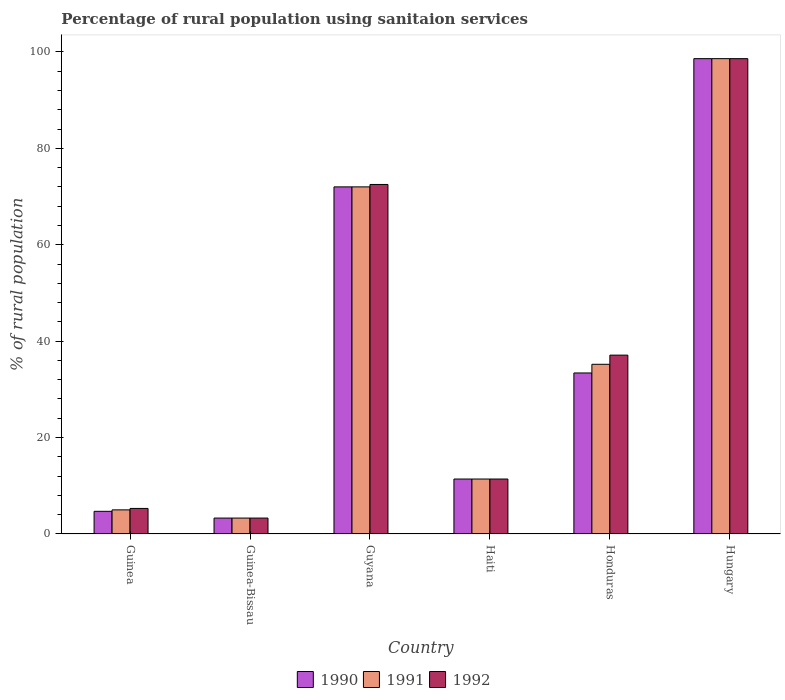How many groups of bars are there?
Offer a very short reply. 6. Are the number of bars per tick equal to the number of legend labels?
Your answer should be compact. Yes. Are the number of bars on each tick of the X-axis equal?
Offer a very short reply. Yes. How many bars are there on the 5th tick from the left?
Keep it short and to the point. 3. How many bars are there on the 1st tick from the right?
Provide a short and direct response. 3. What is the label of the 4th group of bars from the left?
Ensure brevity in your answer.  Haiti. In how many cases, is the number of bars for a given country not equal to the number of legend labels?
Provide a short and direct response. 0. What is the percentage of rural population using sanitaion services in 1990 in Guinea?
Provide a short and direct response. 4.7. Across all countries, what is the maximum percentage of rural population using sanitaion services in 1992?
Your answer should be very brief. 98.6. In which country was the percentage of rural population using sanitaion services in 1990 maximum?
Your answer should be very brief. Hungary. In which country was the percentage of rural population using sanitaion services in 1990 minimum?
Offer a terse response. Guinea-Bissau. What is the total percentage of rural population using sanitaion services in 1992 in the graph?
Provide a short and direct response. 228.2. What is the difference between the percentage of rural population using sanitaion services in 1990 in Guinea-Bissau and the percentage of rural population using sanitaion services in 1991 in Guyana?
Your response must be concise. -68.7. What is the average percentage of rural population using sanitaion services in 1990 per country?
Your answer should be compact. 37.23. In how many countries, is the percentage of rural population using sanitaion services in 1990 greater than 28 %?
Make the answer very short. 3. What is the ratio of the percentage of rural population using sanitaion services in 1992 in Guyana to that in Haiti?
Offer a terse response. 6.36. What is the difference between the highest and the second highest percentage of rural population using sanitaion services in 1990?
Offer a very short reply. 38.6. What is the difference between the highest and the lowest percentage of rural population using sanitaion services in 1992?
Provide a succinct answer. 95.3. In how many countries, is the percentage of rural population using sanitaion services in 1991 greater than the average percentage of rural population using sanitaion services in 1991 taken over all countries?
Make the answer very short. 2. What does the 2nd bar from the right in Guinea represents?
Ensure brevity in your answer.  1991. Are all the bars in the graph horizontal?
Make the answer very short. No. Does the graph contain any zero values?
Provide a short and direct response. No. Where does the legend appear in the graph?
Your answer should be compact. Bottom center. How many legend labels are there?
Offer a very short reply. 3. How are the legend labels stacked?
Provide a succinct answer. Horizontal. What is the title of the graph?
Provide a succinct answer. Percentage of rural population using sanitaion services. What is the label or title of the Y-axis?
Offer a very short reply. % of rural population. What is the % of rural population of 1990 in Guinea?
Ensure brevity in your answer.  4.7. What is the % of rural population in 1991 in Guinea?
Make the answer very short. 5. What is the % of rural population in 1990 in Guinea-Bissau?
Offer a terse response. 3.3. What is the % of rural population in 1991 in Guinea-Bissau?
Give a very brief answer. 3.3. What is the % of rural population of 1990 in Guyana?
Provide a short and direct response. 72. What is the % of rural population of 1992 in Guyana?
Ensure brevity in your answer.  72.5. What is the % of rural population of 1990 in Haiti?
Make the answer very short. 11.4. What is the % of rural population in 1991 in Haiti?
Ensure brevity in your answer.  11.4. What is the % of rural population of 1990 in Honduras?
Your response must be concise. 33.4. What is the % of rural population of 1991 in Honduras?
Make the answer very short. 35.2. What is the % of rural population in 1992 in Honduras?
Ensure brevity in your answer.  37.1. What is the % of rural population of 1990 in Hungary?
Your response must be concise. 98.6. What is the % of rural population in 1991 in Hungary?
Offer a very short reply. 98.6. What is the % of rural population in 1992 in Hungary?
Make the answer very short. 98.6. Across all countries, what is the maximum % of rural population of 1990?
Your response must be concise. 98.6. Across all countries, what is the maximum % of rural population in 1991?
Your answer should be very brief. 98.6. Across all countries, what is the maximum % of rural population in 1992?
Provide a succinct answer. 98.6. Across all countries, what is the minimum % of rural population of 1990?
Give a very brief answer. 3.3. What is the total % of rural population in 1990 in the graph?
Your answer should be compact. 223.4. What is the total % of rural population of 1991 in the graph?
Offer a very short reply. 225.5. What is the total % of rural population in 1992 in the graph?
Your answer should be very brief. 228.2. What is the difference between the % of rural population of 1990 in Guinea and that in Guyana?
Provide a short and direct response. -67.3. What is the difference between the % of rural population of 1991 in Guinea and that in Guyana?
Your answer should be compact. -67. What is the difference between the % of rural population of 1992 in Guinea and that in Guyana?
Provide a succinct answer. -67.2. What is the difference between the % of rural population of 1991 in Guinea and that in Haiti?
Your answer should be very brief. -6.4. What is the difference between the % of rural population in 1990 in Guinea and that in Honduras?
Provide a succinct answer. -28.7. What is the difference between the % of rural population in 1991 in Guinea and that in Honduras?
Make the answer very short. -30.2. What is the difference between the % of rural population in 1992 in Guinea and that in Honduras?
Your answer should be very brief. -31.8. What is the difference between the % of rural population in 1990 in Guinea and that in Hungary?
Your answer should be compact. -93.9. What is the difference between the % of rural population in 1991 in Guinea and that in Hungary?
Ensure brevity in your answer.  -93.6. What is the difference between the % of rural population of 1992 in Guinea and that in Hungary?
Provide a short and direct response. -93.3. What is the difference between the % of rural population in 1990 in Guinea-Bissau and that in Guyana?
Ensure brevity in your answer.  -68.7. What is the difference between the % of rural population in 1991 in Guinea-Bissau and that in Guyana?
Your answer should be very brief. -68.7. What is the difference between the % of rural population in 1992 in Guinea-Bissau and that in Guyana?
Make the answer very short. -69.2. What is the difference between the % of rural population of 1990 in Guinea-Bissau and that in Haiti?
Provide a short and direct response. -8.1. What is the difference between the % of rural population in 1992 in Guinea-Bissau and that in Haiti?
Offer a terse response. -8.1. What is the difference between the % of rural population in 1990 in Guinea-Bissau and that in Honduras?
Offer a terse response. -30.1. What is the difference between the % of rural population in 1991 in Guinea-Bissau and that in Honduras?
Make the answer very short. -31.9. What is the difference between the % of rural population in 1992 in Guinea-Bissau and that in Honduras?
Make the answer very short. -33.8. What is the difference between the % of rural population of 1990 in Guinea-Bissau and that in Hungary?
Provide a short and direct response. -95.3. What is the difference between the % of rural population of 1991 in Guinea-Bissau and that in Hungary?
Your answer should be very brief. -95.3. What is the difference between the % of rural population in 1992 in Guinea-Bissau and that in Hungary?
Your answer should be very brief. -95.3. What is the difference between the % of rural population of 1990 in Guyana and that in Haiti?
Keep it short and to the point. 60.6. What is the difference between the % of rural population of 1991 in Guyana and that in Haiti?
Your answer should be compact. 60.6. What is the difference between the % of rural population in 1992 in Guyana and that in Haiti?
Provide a short and direct response. 61.1. What is the difference between the % of rural population in 1990 in Guyana and that in Honduras?
Keep it short and to the point. 38.6. What is the difference between the % of rural population of 1991 in Guyana and that in Honduras?
Provide a succinct answer. 36.8. What is the difference between the % of rural population in 1992 in Guyana and that in Honduras?
Your answer should be compact. 35.4. What is the difference between the % of rural population of 1990 in Guyana and that in Hungary?
Ensure brevity in your answer.  -26.6. What is the difference between the % of rural population in 1991 in Guyana and that in Hungary?
Your answer should be very brief. -26.6. What is the difference between the % of rural population of 1992 in Guyana and that in Hungary?
Ensure brevity in your answer.  -26.1. What is the difference between the % of rural population of 1990 in Haiti and that in Honduras?
Make the answer very short. -22. What is the difference between the % of rural population of 1991 in Haiti and that in Honduras?
Offer a terse response. -23.8. What is the difference between the % of rural population in 1992 in Haiti and that in Honduras?
Make the answer very short. -25.7. What is the difference between the % of rural population of 1990 in Haiti and that in Hungary?
Keep it short and to the point. -87.2. What is the difference between the % of rural population of 1991 in Haiti and that in Hungary?
Keep it short and to the point. -87.2. What is the difference between the % of rural population in 1992 in Haiti and that in Hungary?
Give a very brief answer. -87.2. What is the difference between the % of rural population in 1990 in Honduras and that in Hungary?
Offer a terse response. -65.2. What is the difference between the % of rural population in 1991 in Honduras and that in Hungary?
Offer a terse response. -63.4. What is the difference between the % of rural population in 1992 in Honduras and that in Hungary?
Give a very brief answer. -61.5. What is the difference between the % of rural population in 1990 in Guinea and the % of rural population in 1991 in Guinea-Bissau?
Ensure brevity in your answer.  1.4. What is the difference between the % of rural population of 1990 in Guinea and the % of rural population of 1992 in Guinea-Bissau?
Provide a short and direct response. 1.4. What is the difference between the % of rural population of 1990 in Guinea and the % of rural population of 1991 in Guyana?
Make the answer very short. -67.3. What is the difference between the % of rural population of 1990 in Guinea and the % of rural population of 1992 in Guyana?
Your response must be concise. -67.8. What is the difference between the % of rural population in 1991 in Guinea and the % of rural population in 1992 in Guyana?
Your answer should be compact. -67.5. What is the difference between the % of rural population in 1990 in Guinea and the % of rural population in 1991 in Haiti?
Your answer should be compact. -6.7. What is the difference between the % of rural population in 1990 in Guinea and the % of rural population in 1992 in Haiti?
Provide a succinct answer. -6.7. What is the difference between the % of rural population in 1990 in Guinea and the % of rural population in 1991 in Honduras?
Offer a very short reply. -30.5. What is the difference between the % of rural population of 1990 in Guinea and the % of rural population of 1992 in Honduras?
Offer a terse response. -32.4. What is the difference between the % of rural population in 1991 in Guinea and the % of rural population in 1992 in Honduras?
Your response must be concise. -32.1. What is the difference between the % of rural population in 1990 in Guinea and the % of rural population in 1991 in Hungary?
Offer a terse response. -93.9. What is the difference between the % of rural population of 1990 in Guinea and the % of rural population of 1992 in Hungary?
Offer a very short reply. -93.9. What is the difference between the % of rural population of 1991 in Guinea and the % of rural population of 1992 in Hungary?
Make the answer very short. -93.6. What is the difference between the % of rural population in 1990 in Guinea-Bissau and the % of rural population in 1991 in Guyana?
Offer a very short reply. -68.7. What is the difference between the % of rural population of 1990 in Guinea-Bissau and the % of rural population of 1992 in Guyana?
Offer a very short reply. -69.2. What is the difference between the % of rural population in 1991 in Guinea-Bissau and the % of rural population in 1992 in Guyana?
Provide a succinct answer. -69.2. What is the difference between the % of rural population in 1990 in Guinea-Bissau and the % of rural population in 1991 in Honduras?
Offer a very short reply. -31.9. What is the difference between the % of rural population in 1990 in Guinea-Bissau and the % of rural population in 1992 in Honduras?
Give a very brief answer. -33.8. What is the difference between the % of rural population of 1991 in Guinea-Bissau and the % of rural population of 1992 in Honduras?
Offer a terse response. -33.8. What is the difference between the % of rural population of 1990 in Guinea-Bissau and the % of rural population of 1991 in Hungary?
Make the answer very short. -95.3. What is the difference between the % of rural population of 1990 in Guinea-Bissau and the % of rural population of 1992 in Hungary?
Ensure brevity in your answer.  -95.3. What is the difference between the % of rural population in 1991 in Guinea-Bissau and the % of rural population in 1992 in Hungary?
Offer a terse response. -95.3. What is the difference between the % of rural population of 1990 in Guyana and the % of rural population of 1991 in Haiti?
Ensure brevity in your answer.  60.6. What is the difference between the % of rural population in 1990 in Guyana and the % of rural population in 1992 in Haiti?
Make the answer very short. 60.6. What is the difference between the % of rural population in 1991 in Guyana and the % of rural population in 1992 in Haiti?
Your answer should be compact. 60.6. What is the difference between the % of rural population of 1990 in Guyana and the % of rural population of 1991 in Honduras?
Ensure brevity in your answer.  36.8. What is the difference between the % of rural population of 1990 in Guyana and the % of rural population of 1992 in Honduras?
Your answer should be very brief. 34.9. What is the difference between the % of rural population in 1991 in Guyana and the % of rural population in 1992 in Honduras?
Offer a terse response. 34.9. What is the difference between the % of rural population in 1990 in Guyana and the % of rural population in 1991 in Hungary?
Your response must be concise. -26.6. What is the difference between the % of rural population of 1990 in Guyana and the % of rural population of 1992 in Hungary?
Your answer should be very brief. -26.6. What is the difference between the % of rural population in 1991 in Guyana and the % of rural population in 1992 in Hungary?
Your response must be concise. -26.6. What is the difference between the % of rural population of 1990 in Haiti and the % of rural population of 1991 in Honduras?
Ensure brevity in your answer.  -23.8. What is the difference between the % of rural population in 1990 in Haiti and the % of rural population in 1992 in Honduras?
Offer a terse response. -25.7. What is the difference between the % of rural population of 1991 in Haiti and the % of rural population of 1992 in Honduras?
Offer a very short reply. -25.7. What is the difference between the % of rural population in 1990 in Haiti and the % of rural population in 1991 in Hungary?
Make the answer very short. -87.2. What is the difference between the % of rural population of 1990 in Haiti and the % of rural population of 1992 in Hungary?
Provide a short and direct response. -87.2. What is the difference between the % of rural population in 1991 in Haiti and the % of rural population in 1992 in Hungary?
Provide a short and direct response. -87.2. What is the difference between the % of rural population in 1990 in Honduras and the % of rural population in 1991 in Hungary?
Offer a very short reply. -65.2. What is the difference between the % of rural population in 1990 in Honduras and the % of rural population in 1992 in Hungary?
Your response must be concise. -65.2. What is the difference between the % of rural population in 1991 in Honduras and the % of rural population in 1992 in Hungary?
Make the answer very short. -63.4. What is the average % of rural population in 1990 per country?
Provide a succinct answer. 37.23. What is the average % of rural population in 1991 per country?
Your answer should be compact. 37.58. What is the average % of rural population in 1992 per country?
Give a very brief answer. 38.03. What is the difference between the % of rural population of 1990 and % of rural population of 1991 in Guinea?
Give a very brief answer. -0.3. What is the difference between the % of rural population of 1991 and % of rural population of 1992 in Guinea?
Provide a succinct answer. -0.3. What is the difference between the % of rural population in 1990 and % of rural population in 1992 in Guinea-Bissau?
Provide a succinct answer. 0. What is the difference between the % of rural population of 1990 and % of rural population of 1991 in Guyana?
Keep it short and to the point. 0. What is the difference between the % of rural population of 1990 and % of rural population of 1991 in Haiti?
Make the answer very short. 0. What is the difference between the % of rural population of 1990 and % of rural population of 1992 in Haiti?
Your answer should be compact. 0. What is the difference between the % of rural population of 1991 and % of rural population of 1992 in Haiti?
Your answer should be compact. 0. What is the difference between the % of rural population in 1990 and % of rural population in 1991 in Hungary?
Keep it short and to the point. 0. What is the difference between the % of rural population of 1990 and % of rural population of 1992 in Hungary?
Make the answer very short. 0. What is the difference between the % of rural population in 1991 and % of rural population in 1992 in Hungary?
Offer a very short reply. 0. What is the ratio of the % of rural population of 1990 in Guinea to that in Guinea-Bissau?
Your answer should be compact. 1.42. What is the ratio of the % of rural population of 1991 in Guinea to that in Guinea-Bissau?
Make the answer very short. 1.52. What is the ratio of the % of rural population of 1992 in Guinea to that in Guinea-Bissau?
Provide a short and direct response. 1.61. What is the ratio of the % of rural population of 1990 in Guinea to that in Guyana?
Offer a terse response. 0.07. What is the ratio of the % of rural population in 1991 in Guinea to that in Guyana?
Your answer should be compact. 0.07. What is the ratio of the % of rural population in 1992 in Guinea to that in Guyana?
Ensure brevity in your answer.  0.07. What is the ratio of the % of rural population of 1990 in Guinea to that in Haiti?
Make the answer very short. 0.41. What is the ratio of the % of rural population in 1991 in Guinea to that in Haiti?
Provide a succinct answer. 0.44. What is the ratio of the % of rural population of 1992 in Guinea to that in Haiti?
Your answer should be compact. 0.46. What is the ratio of the % of rural population of 1990 in Guinea to that in Honduras?
Give a very brief answer. 0.14. What is the ratio of the % of rural population of 1991 in Guinea to that in Honduras?
Your response must be concise. 0.14. What is the ratio of the % of rural population in 1992 in Guinea to that in Honduras?
Your answer should be very brief. 0.14. What is the ratio of the % of rural population in 1990 in Guinea to that in Hungary?
Keep it short and to the point. 0.05. What is the ratio of the % of rural population in 1991 in Guinea to that in Hungary?
Keep it short and to the point. 0.05. What is the ratio of the % of rural population in 1992 in Guinea to that in Hungary?
Offer a terse response. 0.05. What is the ratio of the % of rural population of 1990 in Guinea-Bissau to that in Guyana?
Your response must be concise. 0.05. What is the ratio of the % of rural population in 1991 in Guinea-Bissau to that in Guyana?
Ensure brevity in your answer.  0.05. What is the ratio of the % of rural population in 1992 in Guinea-Bissau to that in Guyana?
Your answer should be very brief. 0.05. What is the ratio of the % of rural population in 1990 in Guinea-Bissau to that in Haiti?
Provide a succinct answer. 0.29. What is the ratio of the % of rural population of 1991 in Guinea-Bissau to that in Haiti?
Your answer should be compact. 0.29. What is the ratio of the % of rural population of 1992 in Guinea-Bissau to that in Haiti?
Make the answer very short. 0.29. What is the ratio of the % of rural population of 1990 in Guinea-Bissau to that in Honduras?
Keep it short and to the point. 0.1. What is the ratio of the % of rural population of 1991 in Guinea-Bissau to that in Honduras?
Your answer should be compact. 0.09. What is the ratio of the % of rural population of 1992 in Guinea-Bissau to that in Honduras?
Provide a succinct answer. 0.09. What is the ratio of the % of rural population in 1990 in Guinea-Bissau to that in Hungary?
Keep it short and to the point. 0.03. What is the ratio of the % of rural population of 1991 in Guinea-Bissau to that in Hungary?
Offer a terse response. 0.03. What is the ratio of the % of rural population of 1992 in Guinea-Bissau to that in Hungary?
Offer a very short reply. 0.03. What is the ratio of the % of rural population in 1990 in Guyana to that in Haiti?
Ensure brevity in your answer.  6.32. What is the ratio of the % of rural population of 1991 in Guyana to that in Haiti?
Provide a short and direct response. 6.32. What is the ratio of the % of rural population of 1992 in Guyana to that in Haiti?
Provide a succinct answer. 6.36. What is the ratio of the % of rural population of 1990 in Guyana to that in Honduras?
Your response must be concise. 2.16. What is the ratio of the % of rural population of 1991 in Guyana to that in Honduras?
Provide a succinct answer. 2.05. What is the ratio of the % of rural population of 1992 in Guyana to that in Honduras?
Make the answer very short. 1.95. What is the ratio of the % of rural population of 1990 in Guyana to that in Hungary?
Keep it short and to the point. 0.73. What is the ratio of the % of rural population in 1991 in Guyana to that in Hungary?
Your response must be concise. 0.73. What is the ratio of the % of rural population of 1992 in Guyana to that in Hungary?
Your answer should be very brief. 0.74. What is the ratio of the % of rural population in 1990 in Haiti to that in Honduras?
Offer a very short reply. 0.34. What is the ratio of the % of rural population in 1991 in Haiti to that in Honduras?
Your answer should be very brief. 0.32. What is the ratio of the % of rural population of 1992 in Haiti to that in Honduras?
Offer a terse response. 0.31. What is the ratio of the % of rural population of 1990 in Haiti to that in Hungary?
Provide a short and direct response. 0.12. What is the ratio of the % of rural population in 1991 in Haiti to that in Hungary?
Your answer should be very brief. 0.12. What is the ratio of the % of rural population of 1992 in Haiti to that in Hungary?
Provide a short and direct response. 0.12. What is the ratio of the % of rural population in 1990 in Honduras to that in Hungary?
Keep it short and to the point. 0.34. What is the ratio of the % of rural population in 1991 in Honduras to that in Hungary?
Provide a succinct answer. 0.36. What is the ratio of the % of rural population of 1992 in Honduras to that in Hungary?
Provide a succinct answer. 0.38. What is the difference between the highest and the second highest % of rural population of 1990?
Make the answer very short. 26.6. What is the difference between the highest and the second highest % of rural population in 1991?
Your response must be concise. 26.6. What is the difference between the highest and the second highest % of rural population in 1992?
Give a very brief answer. 26.1. What is the difference between the highest and the lowest % of rural population in 1990?
Your response must be concise. 95.3. What is the difference between the highest and the lowest % of rural population in 1991?
Make the answer very short. 95.3. What is the difference between the highest and the lowest % of rural population in 1992?
Your response must be concise. 95.3. 